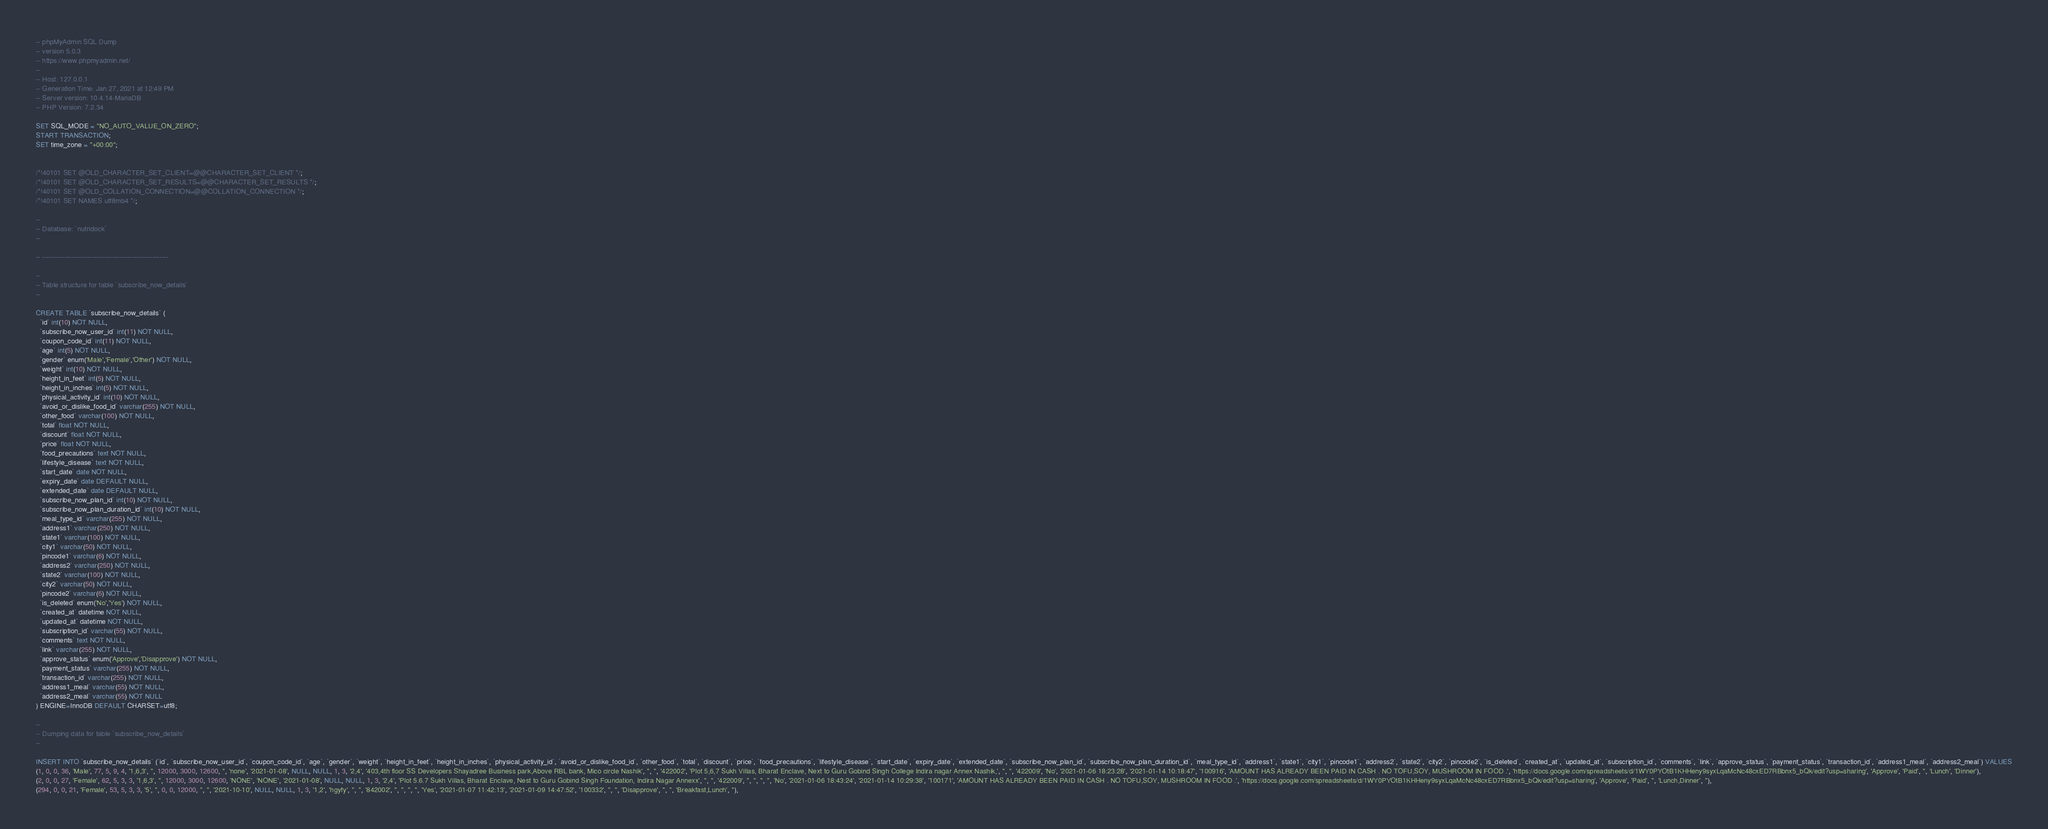Convert code to text. <code><loc_0><loc_0><loc_500><loc_500><_SQL_>-- phpMyAdmin SQL Dump
-- version 5.0.3
-- https://www.phpmyadmin.net/
--
-- Host: 127.0.0.1
-- Generation Time: Jan 27, 2021 at 12:49 PM
-- Server version: 10.4.14-MariaDB
-- PHP Version: 7.2.34

SET SQL_MODE = "NO_AUTO_VALUE_ON_ZERO";
START TRANSACTION;
SET time_zone = "+00:00";


/*!40101 SET @OLD_CHARACTER_SET_CLIENT=@@CHARACTER_SET_CLIENT */;
/*!40101 SET @OLD_CHARACTER_SET_RESULTS=@@CHARACTER_SET_RESULTS */;
/*!40101 SET @OLD_COLLATION_CONNECTION=@@COLLATION_CONNECTION */;
/*!40101 SET NAMES utf8mb4 */;

--
-- Database: `nutridock`
--

-- --------------------------------------------------------

--
-- Table structure for table `subscribe_now_details`
--

CREATE TABLE `subscribe_now_details` (
  `id` int(10) NOT NULL,
  `subscribe_now_user_id` int(11) NOT NULL,
  `coupon_code_id` int(11) NOT NULL,
  `age` int(5) NOT NULL,
  `gender` enum('Male','Female','Other') NOT NULL,
  `weight` int(10) NOT NULL,
  `height_in_feet` int(5) NOT NULL,
  `height_in_inches` int(5) NOT NULL,
  `physical_activity_id` int(10) NOT NULL,
  `avoid_or_dislike_food_id` varchar(255) NOT NULL,
  `other_food` varchar(100) NOT NULL,
  `total` float NOT NULL,
  `discount` float NOT NULL,
  `price` float NOT NULL,
  `food_precautions` text NOT NULL,
  `lifestyle_disease` text NOT NULL,
  `start_date` date NOT NULL,
  `expiry_date` date DEFAULT NULL,
  `extended_date` date DEFAULT NULL,
  `subscribe_now_plan_id` int(10) NOT NULL,
  `subscribe_now_plan_duration_id` int(10) NOT NULL,
  `meal_type_id` varchar(255) NOT NULL,
  `address1` varchar(250) NOT NULL,
  `state1` varchar(100) NOT NULL,
  `city1` varchar(50) NOT NULL,
  `pincode1` varchar(6) NOT NULL,
  `address2` varchar(250) NOT NULL,
  `state2` varchar(100) NOT NULL,
  `city2` varchar(50) NOT NULL,
  `pincode2` varchar(6) NOT NULL,
  `is_deleted` enum('No','Yes') NOT NULL,
  `created_at` datetime NOT NULL,
  `updated_at` datetime NOT NULL,
  `subscription_id` varchar(55) NOT NULL,
  `comments` text NOT NULL,
  `link` varchar(255) NOT NULL,
  `approve_status` enum('Approve','Disapprove') NOT NULL,
  `payment_status` varchar(255) NOT NULL,
  `transaction_id` varchar(255) NOT NULL,
  `address1_meal` varchar(55) NOT NULL,
  `address2_meal` varchar(55) NOT NULL
) ENGINE=InnoDB DEFAULT CHARSET=utf8;

--
-- Dumping data for table `subscribe_now_details`
--

INSERT INTO `subscribe_now_details` (`id`, `subscribe_now_user_id`, `coupon_code_id`, `age`, `gender`, `weight`, `height_in_feet`, `height_in_inches`, `physical_activity_id`, `avoid_or_dislike_food_id`, `other_food`, `total`, `discount`, `price`, `food_precautions`, `lifestyle_disease`, `start_date`, `expiry_date`, `extended_date`, `subscribe_now_plan_id`, `subscribe_now_plan_duration_id`, `meal_type_id`, `address1`, `state1`, `city1`, `pincode1`, `address2`, `state2`, `city2`, `pincode2`, `is_deleted`, `created_at`, `updated_at`, `subscription_id`, `comments`, `link`, `approve_status`, `payment_status`, `transaction_id`, `address1_meal`, `address2_meal`) VALUES
(1, 0, 0, 36, 'Male', 77, 5, 9, 4, '1,6,3', '', 12000, 3000, 12600, '', 'none', '2021-01-08', NULL, NULL, 1, 3, '2,4', '403,4th floor SS Developers Shayadree Business park,Above RBL bank, Mico circle Nashik', '', '', '422002', 'Plot 5,6,7 Sukh Villas, Bharat Enclave, Next to Guru Gobind Singh College Indira nagar Annex Nashik,', '', '', '422009', 'No', '2021-01-06 18:23:28', '2021-01-14 10:18:47', '100916', 'AMOUNT HAS ALREADY BEEN PAID IN CASH . NO TOFU,SOY, MUSHROOM IN FOOD .', 'https://docs.google.com/spreadsheets/d/1WY0PYOtB1KHHeny9syxLqaMcNc48cxED7RBbnx5_bQk/edit?usp=sharing', 'Approve', 'Paid', '', 'Lunch', 'Dinner'),
(2, 0, 0, 27, 'Female', 62, 5, 3, 3, '1,6,3', '', 12000, 3000, 12600, 'NONE', 'NONE', '2021-01-08', NULL, NULL, 1, 3, '2,4', 'Plot 5.6.7 Sukh Villas, Bharat Enclave, Nest to Guru Gobind Singh Foundation, Indira Nagar Annexx', '', '', '422009', '', '', '', '', 'No', '2021-01-06 18:43:24', '2021-01-14 10:29:38', '100171', 'AMOUNT HAS ALREADY BEEN PAID IN CASH . NO TOFU,SOY, MUSHROOM IN FOOD .', 'https://docs.google.com/spreadsheets/d/1WY0PYOtB1KHHeny9syxLqaMcNc48cxED7RBbnx5_bQk/edit?usp=sharing', 'Approve', 'Paid', '', 'Lunch,Dinner', ''),
(294, 0, 0, 21, 'Female', 53, 5, 3, 3, '5', '', 0, 0, 12000, '', '', '2021-10-10', NULL, NULL, 1, 3, '1,2', 'hgyfy', '', '', '842002', '', '', '', '', 'Yes', '2021-01-07 11:42:13', '2021-01-09 14:47:52', '100332', '', '', 'Disapprove', '', '', 'Breakfast,Lunch', ''),</code> 